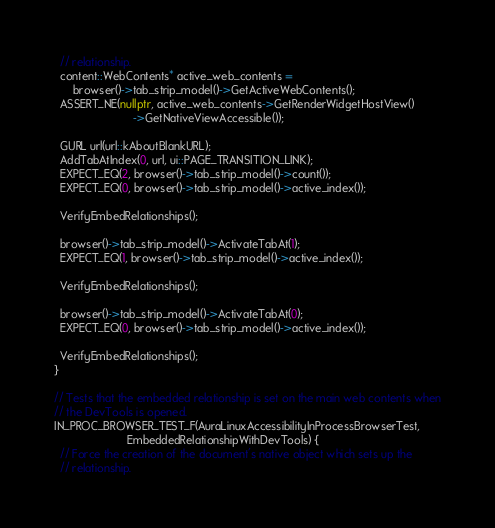<code> <loc_0><loc_0><loc_500><loc_500><_C++_>  // relationship.
  content::WebContents* active_web_contents =
      browser()->tab_strip_model()->GetActiveWebContents();
  ASSERT_NE(nullptr, active_web_contents->GetRenderWidgetHostView()
                         ->GetNativeViewAccessible());

  GURL url(url::kAboutBlankURL);
  AddTabAtIndex(0, url, ui::PAGE_TRANSITION_LINK);
  EXPECT_EQ(2, browser()->tab_strip_model()->count());
  EXPECT_EQ(0, browser()->tab_strip_model()->active_index());

  VerifyEmbedRelationships();

  browser()->tab_strip_model()->ActivateTabAt(1);
  EXPECT_EQ(1, browser()->tab_strip_model()->active_index());

  VerifyEmbedRelationships();

  browser()->tab_strip_model()->ActivateTabAt(0);
  EXPECT_EQ(0, browser()->tab_strip_model()->active_index());

  VerifyEmbedRelationships();
}

// Tests that the embedded relationship is set on the main web contents when
// the DevTools is opened.
IN_PROC_BROWSER_TEST_F(AuraLinuxAccessibilityInProcessBrowserTest,
                       EmbeddedRelationshipWithDevTools) {
  // Force the creation of the document's native object which sets up the
  // relationship.</code> 